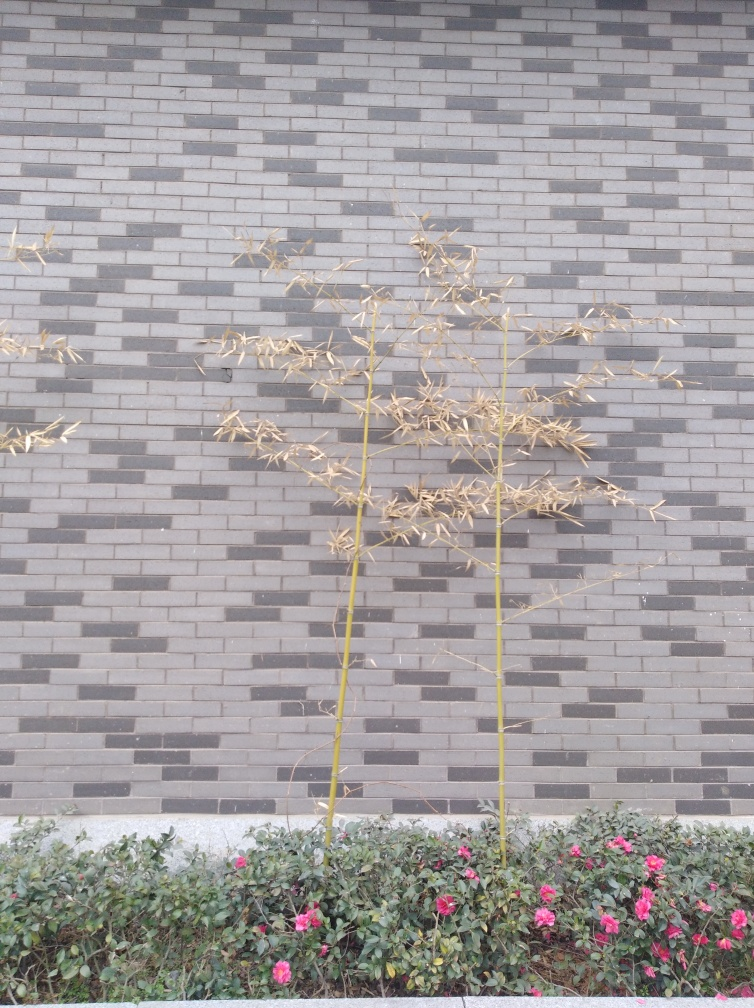How might this scene look different in another season? In a different season, such as spring or summer, the dried plants may have been replaced with freshly bloomed foliage or flowers. The contrast would be less stark, with a more uniform, lush greenery, and a broader spectrum of colors from a variety of blooming flowers. 